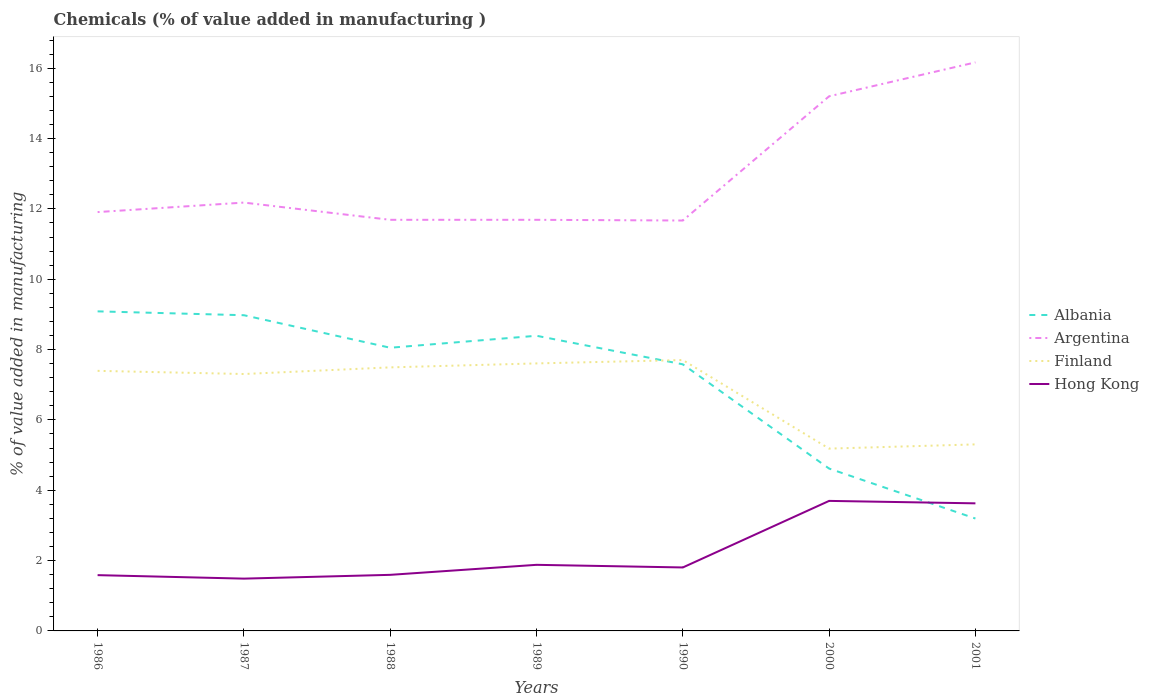How many different coloured lines are there?
Your response must be concise. 4. Does the line corresponding to Albania intersect with the line corresponding to Argentina?
Keep it short and to the point. No. Across all years, what is the maximum value added in manufacturing chemicals in Argentina?
Give a very brief answer. 11.67. In which year was the value added in manufacturing chemicals in Albania maximum?
Offer a terse response. 2001. What is the total value added in manufacturing chemicals in Argentina in the graph?
Your answer should be compact. 0.51. What is the difference between the highest and the second highest value added in manufacturing chemicals in Hong Kong?
Your answer should be compact. 2.21. What is the difference between the highest and the lowest value added in manufacturing chemicals in Finland?
Your response must be concise. 5. Does the graph contain grids?
Your response must be concise. No. What is the title of the graph?
Your answer should be very brief. Chemicals (% of value added in manufacturing ). What is the label or title of the Y-axis?
Offer a terse response. % of value added in manufacturing. What is the % of value added in manufacturing of Albania in 1986?
Ensure brevity in your answer.  9.09. What is the % of value added in manufacturing of Argentina in 1986?
Ensure brevity in your answer.  11.91. What is the % of value added in manufacturing of Finland in 1986?
Keep it short and to the point. 7.4. What is the % of value added in manufacturing of Hong Kong in 1986?
Your answer should be very brief. 1.59. What is the % of value added in manufacturing in Albania in 1987?
Your answer should be very brief. 8.98. What is the % of value added in manufacturing in Argentina in 1987?
Keep it short and to the point. 12.18. What is the % of value added in manufacturing in Finland in 1987?
Keep it short and to the point. 7.31. What is the % of value added in manufacturing in Hong Kong in 1987?
Provide a succinct answer. 1.49. What is the % of value added in manufacturing of Albania in 1988?
Provide a succinct answer. 8.05. What is the % of value added in manufacturing of Argentina in 1988?
Provide a short and direct response. 11.69. What is the % of value added in manufacturing of Finland in 1988?
Provide a succinct answer. 7.49. What is the % of value added in manufacturing in Hong Kong in 1988?
Offer a very short reply. 1.59. What is the % of value added in manufacturing of Albania in 1989?
Ensure brevity in your answer.  8.39. What is the % of value added in manufacturing of Argentina in 1989?
Your answer should be very brief. 11.69. What is the % of value added in manufacturing in Finland in 1989?
Give a very brief answer. 7.61. What is the % of value added in manufacturing in Hong Kong in 1989?
Offer a very short reply. 1.88. What is the % of value added in manufacturing in Albania in 1990?
Offer a terse response. 7.58. What is the % of value added in manufacturing in Argentina in 1990?
Provide a short and direct response. 11.67. What is the % of value added in manufacturing in Finland in 1990?
Offer a very short reply. 7.7. What is the % of value added in manufacturing of Hong Kong in 1990?
Your answer should be very brief. 1.8. What is the % of value added in manufacturing in Albania in 2000?
Offer a very short reply. 4.62. What is the % of value added in manufacturing of Argentina in 2000?
Your answer should be compact. 15.2. What is the % of value added in manufacturing in Finland in 2000?
Ensure brevity in your answer.  5.18. What is the % of value added in manufacturing in Hong Kong in 2000?
Your answer should be very brief. 3.7. What is the % of value added in manufacturing in Albania in 2001?
Offer a terse response. 3.2. What is the % of value added in manufacturing in Argentina in 2001?
Your answer should be very brief. 16.17. What is the % of value added in manufacturing in Finland in 2001?
Your response must be concise. 5.3. What is the % of value added in manufacturing of Hong Kong in 2001?
Offer a terse response. 3.63. Across all years, what is the maximum % of value added in manufacturing of Albania?
Keep it short and to the point. 9.09. Across all years, what is the maximum % of value added in manufacturing in Argentina?
Ensure brevity in your answer.  16.17. Across all years, what is the maximum % of value added in manufacturing in Finland?
Make the answer very short. 7.7. Across all years, what is the maximum % of value added in manufacturing in Hong Kong?
Offer a very short reply. 3.7. Across all years, what is the minimum % of value added in manufacturing in Albania?
Provide a short and direct response. 3.2. Across all years, what is the minimum % of value added in manufacturing in Argentina?
Your answer should be very brief. 11.67. Across all years, what is the minimum % of value added in manufacturing in Finland?
Offer a very short reply. 5.18. Across all years, what is the minimum % of value added in manufacturing of Hong Kong?
Make the answer very short. 1.49. What is the total % of value added in manufacturing of Albania in the graph?
Your response must be concise. 49.9. What is the total % of value added in manufacturing in Argentina in the graph?
Provide a short and direct response. 90.51. What is the total % of value added in manufacturing of Finland in the graph?
Ensure brevity in your answer.  47.99. What is the total % of value added in manufacturing in Hong Kong in the graph?
Give a very brief answer. 15.68. What is the difference between the % of value added in manufacturing of Albania in 1986 and that in 1987?
Offer a terse response. 0.11. What is the difference between the % of value added in manufacturing of Argentina in 1986 and that in 1987?
Your response must be concise. -0.27. What is the difference between the % of value added in manufacturing in Finland in 1986 and that in 1987?
Your response must be concise. 0.09. What is the difference between the % of value added in manufacturing of Hong Kong in 1986 and that in 1987?
Ensure brevity in your answer.  0.1. What is the difference between the % of value added in manufacturing in Albania in 1986 and that in 1988?
Provide a succinct answer. 1.03. What is the difference between the % of value added in manufacturing in Argentina in 1986 and that in 1988?
Give a very brief answer. 0.22. What is the difference between the % of value added in manufacturing in Finland in 1986 and that in 1988?
Your answer should be very brief. -0.1. What is the difference between the % of value added in manufacturing in Hong Kong in 1986 and that in 1988?
Keep it short and to the point. -0.01. What is the difference between the % of value added in manufacturing of Albania in 1986 and that in 1989?
Ensure brevity in your answer.  0.69. What is the difference between the % of value added in manufacturing in Argentina in 1986 and that in 1989?
Offer a very short reply. 0.22. What is the difference between the % of value added in manufacturing in Finland in 1986 and that in 1989?
Provide a succinct answer. -0.21. What is the difference between the % of value added in manufacturing in Hong Kong in 1986 and that in 1989?
Make the answer very short. -0.29. What is the difference between the % of value added in manufacturing of Albania in 1986 and that in 1990?
Offer a terse response. 1.51. What is the difference between the % of value added in manufacturing of Argentina in 1986 and that in 1990?
Your answer should be compact. 0.24. What is the difference between the % of value added in manufacturing in Finland in 1986 and that in 1990?
Give a very brief answer. -0.31. What is the difference between the % of value added in manufacturing in Hong Kong in 1986 and that in 1990?
Offer a very short reply. -0.22. What is the difference between the % of value added in manufacturing in Albania in 1986 and that in 2000?
Ensure brevity in your answer.  4.47. What is the difference between the % of value added in manufacturing of Argentina in 1986 and that in 2000?
Your answer should be very brief. -3.29. What is the difference between the % of value added in manufacturing in Finland in 1986 and that in 2000?
Provide a short and direct response. 2.21. What is the difference between the % of value added in manufacturing of Hong Kong in 1986 and that in 2000?
Keep it short and to the point. -2.11. What is the difference between the % of value added in manufacturing of Albania in 1986 and that in 2001?
Ensure brevity in your answer.  5.89. What is the difference between the % of value added in manufacturing of Argentina in 1986 and that in 2001?
Ensure brevity in your answer.  -4.26. What is the difference between the % of value added in manufacturing of Finland in 1986 and that in 2001?
Keep it short and to the point. 2.09. What is the difference between the % of value added in manufacturing in Hong Kong in 1986 and that in 2001?
Give a very brief answer. -2.04. What is the difference between the % of value added in manufacturing of Albania in 1987 and that in 1988?
Provide a succinct answer. 0.92. What is the difference between the % of value added in manufacturing in Argentina in 1987 and that in 1988?
Keep it short and to the point. 0.49. What is the difference between the % of value added in manufacturing of Finland in 1987 and that in 1988?
Make the answer very short. -0.19. What is the difference between the % of value added in manufacturing of Hong Kong in 1987 and that in 1988?
Provide a succinct answer. -0.11. What is the difference between the % of value added in manufacturing of Albania in 1987 and that in 1989?
Offer a terse response. 0.58. What is the difference between the % of value added in manufacturing of Argentina in 1987 and that in 1989?
Your response must be concise. 0.49. What is the difference between the % of value added in manufacturing of Finland in 1987 and that in 1989?
Give a very brief answer. -0.3. What is the difference between the % of value added in manufacturing in Hong Kong in 1987 and that in 1989?
Make the answer very short. -0.39. What is the difference between the % of value added in manufacturing of Albania in 1987 and that in 1990?
Offer a terse response. 1.4. What is the difference between the % of value added in manufacturing of Argentina in 1987 and that in 1990?
Make the answer very short. 0.51. What is the difference between the % of value added in manufacturing in Finland in 1987 and that in 1990?
Give a very brief answer. -0.4. What is the difference between the % of value added in manufacturing in Hong Kong in 1987 and that in 1990?
Offer a terse response. -0.32. What is the difference between the % of value added in manufacturing in Albania in 1987 and that in 2000?
Give a very brief answer. 4.36. What is the difference between the % of value added in manufacturing of Argentina in 1987 and that in 2000?
Provide a succinct answer. -3.02. What is the difference between the % of value added in manufacturing in Finland in 1987 and that in 2000?
Offer a terse response. 2.12. What is the difference between the % of value added in manufacturing in Hong Kong in 1987 and that in 2000?
Offer a terse response. -2.21. What is the difference between the % of value added in manufacturing of Albania in 1987 and that in 2001?
Offer a very short reply. 5.78. What is the difference between the % of value added in manufacturing of Argentina in 1987 and that in 2001?
Make the answer very short. -3.99. What is the difference between the % of value added in manufacturing in Finland in 1987 and that in 2001?
Your response must be concise. 2. What is the difference between the % of value added in manufacturing in Hong Kong in 1987 and that in 2001?
Ensure brevity in your answer.  -2.14. What is the difference between the % of value added in manufacturing in Albania in 1988 and that in 1989?
Make the answer very short. -0.34. What is the difference between the % of value added in manufacturing of Argentina in 1988 and that in 1989?
Your answer should be compact. 0. What is the difference between the % of value added in manufacturing of Finland in 1988 and that in 1989?
Offer a terse response. -0.11. What is the difference between the % of value added in manufacturing of Hong Kong in 1988 and that in 1989?
Keep it short and to the point. -0.28. What is the difference between the % of value added in manufacturing in Albania in 1988 and that in 1990?
Give a very brief answer. 0.47. What is the difference between the % of value added in manufacturing in Argentina in 1988 and that in 1990?
Make the answer very short. 0.02. What is the difference between the % of value added in manufacturing in Finland in 1988 and that in 1990?
Ensure brevity in your answer.  -0.21. What is the difference between the % of value added in manufacturing of Hong Kong in 1988 and that in 1990?
Keep it short and to the point. -0.21. What is the difference between the % of value added in manufacturing in Albania in 1988 and that in 2000?
Keep it short and to the point. 3.44. What is the difference between the % of value added in manufacturing of Argentina in 1988 and that in 2000?
Offer a very short reply. -3.51. What is the difference between the % of value added in manufacturing of Finland in 1988 and that in 2000?
Offer a terse response. 2.31. What is the difference between the % of value added in manufacturing of Hong Kong in 1988 and that in 2000?
Your answer should be compact. -2.1. What is the difference between the % of value added in manufacturing in Albania in 1988 and that in 2001?
Ensure brevity in your answer.  4.86. What is the difference between the % of value added in manufacturing of Argentina in 1988 and that in 2001?
Your answer should be very brief. -4.48. What is the difference between the % of value added in manufacturing of Finland in 1988 and that in 2001?
Provide a succinct answer. 2.19. What is the difference between the % of value added in manufacturing in Hong Kong in 1988 and that in 2001?
Make the answer very short. -2.03. What is the difference between the % of value added in manufacturing of Albania in 1989 and that in 1990?
Offer a terse response. 0.81. What is the difference between the % of value added in manufacturing of Finland in 1989 and that in 1990?
Keep it short and to the point. -0.1. What is the difference between the % of value added in manufacturing in Hong Kong in 1989 and that in 1990?
Your answer should be very brief. 0.07. What is the difference between the % of value added in manufacturing of Albania in 1989 and that in 2000?
Ensure brevity in your answer.  3.78. What is the difference between the % of value added in manufacturing of Argentina in 1989 and that in 2000?
Make the answer very short. -3.51. What is the difference between the % of value added in manufacturing of Finland in 1989 and that in 2000?
Offer a terse response. 2.42. What is the difference between the % of value added in manufacturing in Hong Kong in 1989 and that in 2000?
Your answer should be very brief. -1.82. What is the difference between the % of value added in manufacturing in Albania in 1989 and that in 2001?
Provide a succinct answer. 5.2. What is the difference between the % of value added in manufacturing in Argentina in 1989 and that in 2001?
Offer a terse response. -4.48. What is the difference between the % of value added in manufacturing of Finland in 1989 and that in 2001?
Your answer should be very brief. 2.3. What is the difference between the % of value added in manufacturing in Hong Kong in 1989 and that in 2001?
Offer a terse response. -1.75. What is the difference between the % of value added in manufacturing in Albania in 1990 and that in 2000?
Offer a very short reply. 2.96. What is the difference between the % of value added in manufacturing in Argentina in 1990 and that in 2000?
Make the answer very short. -3.53. What is the difference between the % of value added in manufacturing of Finland in 1990 and that in 2000?
Keep it short and to the point. 2.52. What is the difference between the % of value added in manufacturing in Hong Kong in 1990 and that in 2000?
Make the answer very short. -1.89. What is the difference between the % of value added in manufacturing in Albania in 1990 and that in 2001?
Provide a succinct answer. 4.39. What is the difference between the % of value added in manufacturing of Argentina in 1990 and that in 2001?
Ensure brevity in your answer.  -4.5. What is the difference between the % of value added in manufacturing in Finland in 1990 and that in 2001?
Provide a short and direct response. 2.4. What is the difference between the % of value added in manufacturing in Hong Kong in 1990 and that in 2001?
Provide a short and direct response. -1.82. What is the difference between the % of value added in manufacturing in Albania in 2000 and that in 2001?
Your answer should be compact. 1.42. What is the difference between the % of value added in manufacturing in Argentina in 2000 and that in 2001?
Ensure brevity in your answer.  -0.96. What is the difference between the % of value added in manufacturing in Finland in 2000 and that in 2001?
Keep it short and to the point. -0.12. What is the difference between the % of value added in manufacturing in Hong Kong in 2000 and that in 2001?
Your response must be concise. 0.07. What is the difference between the % of value added in manufacturing in Albania in 1986 and the % of value added in manufacturing in Argentina in 1987?
Offer a terse response. -3.09. What is the difference between the % of value added in manufacturing of Albania in 1986 and the % of value added in manufacturing of Finland in 1987?
Your answer should be compact. 1.78. What is the difference between the % of value added in manufacturing of Albania in 1986 and the % of value added in manufacturing of Hong Kong in 1987?
Ensure brevity in your answer.  7.6. What is the difference between the % of value added in manufacturing of Argentina in 1986 and the % of value added in manufacturing of Finland in 1987?
Your answer should be compact. 4.6. What is the difference between the % of value added in manufacturing in Argentina in 1986 and the % of value added in manufacturing in Hong Kong in 1987?
Your answer should be very brief. 10.42. What is the difference between the % of value added in manufacturing in Finland in 1986 and the % of value added in manufacturing in Hong Kong in 1987?
Ensure brevity in your answer.  5.91. What is the difference between the % of value added in manufacturing in Albania in 1986 and the % of value added in manufacturing in Argentina in 1988?
Ensure brevity in your answer.  -2.6. What is the difference between the % of value added in manufacturing of Albania in 1986 and the % of value added in manufacturing of Finland in 1988?
Your answer should be very brief. 1.59. What is the difference between the % of value added in manufacturing of Albania in 1986 and the % of value added in manufacturing of Hong Kong in 1988?
Offer a terse response. 7.49. What is the difference between the % of value added in manufacturing of Argentina in 1986 and the % of value added in manufacturing of Finland in 1988?
Offer a terse response. 4.42. What is the difference between the % of value added in manufacturing of Argentina in 1986 and the % of value added in manufacturing of Hong Kong in 1988?
Offer a very short reply. 10.32. What is the difference between the % of value added in manufacturing of Finland in 1986 and the % of value added in manufacturing of Hong Kong in 1988?
Keep it short and to the point. 5.8. What is the difference between the % of value added in manufacturing in Albania in 1986 and the % of value added in manufacturing in Argentina in 1989?
Your answer should be very brief. -2.6. What is the difference between the % of value added in manufacturing in Albania in 1986 and the % of value added in manufacturing in Finland in 1989?
Your answer should be very brief. 1.48. What is the difference between the % of value added in manufacturing of Albania in 1986 and the % of value added in manufacturing of Hong Kong in 1989?
Provide a succinct answer. 7.21. What is the difference between the % of value added in manufacturing in Argentina in 1986 and the % of value added in manufacturing in Finland in 1989?
Ensure brevity in your answer.  4.3. What is the difference between the % of value added in manufacturing of Argentina in 1986 and the % of value added in manufacturing of Hong Kong in 1989?
Your response must be concise. 10.03. What is the difference between the % of value added in manufacturing of Finland in 1986 and the % of value added in manufacturing of Hong Kong in 1989?
Offer a very short reply. 5.52. What is the difference between the % of value added in manufacturing in Albania in 1986 and the % of value added in manufacturing in Argentina in 1990?
Your answer should be compact. -2.58. What is the difference between the % of value added in manufacturing of Albania in 1986 and the % of value added in manufacturing of Finland in 1990?
Offer a very short reply. 1.38. What is the difference between the % of value added in manufacturing of Albania in 1986 and the % of value added in manufacturing of Hong Kong in 1990?
Keep it short and to the point. 7.28. What is the difference between the % of value added in manufacturing of Argentina in 1986 and the % of value added in manufacturing of Finland in 1990?
Offer a terse response. 4.21. What is the difference between the % of value added in manufacturing in Argentina in 1986 and the % of value added in manufacturing in Hong Kong in 1990?
Your answer should be compact. 10.11. What is the difference between the % of value added in manufacturing in Finland in 1986 and the % of value added in manufacturing in Hong Kong in 1990?
Your response must be concise. 5.59. What is the difference between the % of value added in manufacturing of Albania in 1986 and the % of value added in manufacturing of Argentina in 2000?
Ensure brevity in your answer.  -6.12. What is the difference between the % of value added in manufacturing in Albania in 1986 and the % of value added in manufacturing in Finland in 2000?
Ensure brevity in your answer.  3.9. What is the difference between the % of value added in manufacturing of Albania in 1986 and the % of value added in manufacturing of Hong Kong in 2000?
Your answer should be very brief. 5.39. What is the difference between the % of value added in manufacturing of Argentina in 1986 and the % of value added in manufacturing of Finland in 2000?
Your response must be concise. 6.73. What is the difference between the % of value added in manufacturing of Argentina in 1986 and the % of value added in manufacturing of Hong Kong in 2000?
Your answer should be compact. 8.21. What is the difference between the % of value added in manufacturing in Finland in 1986 and the % of value added in manufacturing in Hong Kong in 2000?
Offer a terse response. 3.7. What is the difference between the % of value added in manufacturing in Albania in 1986 and the % of value added in manufacturing in Argentina in 2001?
Provide a succinct answer. -7.08. What is the difference between the % of value added in manufacturing in Albania in 1986 and the % of value added in manufacturing in Finland in 2001?
Your answer should be very brief. 3.78. What is the difference between the % of value added in manufacturing in Albania in 1986 and the % of value added in manufacturing in Hong Kong in 2001?
Offer a terse response. 5.46. What is the difference between the % of value added in manufacturing in Argentina in 1986 and the % of value added in manufacturing in Finland in 2001?
Your response must be concise. 6.61. What is the difference between the % of value added in manufacturing in Argentina in 1986 and the % of value added in manufacturing in Hong Kong in 2001?
Provide a short and direct response. 8.28. What is the difference between the % of value added in manufacturing in Finland in 1986 and the % of value added in manufacturing in Hong Kong in 2001?
Offer a very short reply. 3.77. What is the difference between the % of value added in manufacturing of Albania in 1987 and the % of value added in manufacturing of Argentina in 1988?
Give a very brief answer. -2.71. What is the difference between the % of value added in manufacturing in Albania in 1987 and the % of value added in manufacturing in Finland in 1988?
Offer a very short reply. 1.48. What is the difference between the % of value added in manufacturing of Albania in 1987 and the % of value added in manufacturing of Hong Kong in 1988?
Ensure brevity in your answer.  7.38. What is the difference between the % of value added in manufacturing in Argentina in 1987 and the % of value added in manufacturing in Finland in 1988?
Keep it short and to the point. 4.69. What is the difference between the % of value added in manufacturing of Argentina in 1987 and the % of value added in manufacturing of Hong Kong in 1988?
Offer a very short reply. 10.59. What is the difference between the % of value added in manufacturing of Finland in 1987 and the % of value added in manufacturing of Hong Kong in 1988?
Give a very brief answer. 5.71. What is the difference between the % of value added in manufacturing in Albania in 1987 and the % of value added in manufacturing in Argentina in 1989?
Provide a short and direct response. -2.71. What is the difference between the % of value added in manufacturing of Albania in 1987 and the % of value added in manufacturing of Finland in 1989?
Make the answer very short. 1.37. What is the difference between the % of value added in manufacturing in Albania in 1987 and the % of value added in manufacturing in Hong Kong in 1989?
Your response must be concise. 7.1. What is the difference between the % of value added in manufacturing of Argentina in 1987 and the % of value added in manufacturing of Finland in 1989?
Give a very brief answer. 4.57. What is the difference between the % of value added in manufacturing in Argentina in 1987 and the % of value added in manufacturing in Hong Kong in 1989?
Your response must be concise. 10.3. What is the difference between the % of value added in manufacturing in Finland in 1987 and the % of value added in manufacturing in Hong Kong in 1989?
Your answer should be very brief. 5.43. What is the difference between the % of value added in manufacturing of Albania in 1987 and the % of value added in manufacturing of Argentina in 1990?
Give a very brief answer. -2.69. What is the difference between the % of value added in manufacturing of Albania in 1987 and the % of value added in manufacturing of Finland in 1990?
Your response must be concise. 1.27. What is the difference between the % of value added in manufacturing of Albania in 1987 and the % of value added in manufacturing of Hong Kong in 1990?
Keep it short and to the point. 7.17. What is the difference between the % of value added in manufacturing of Argentina in 1987 and the % of value added in manufacturing of Finland in 1990?
Offer a terse response. 4.48. What is the difference between the % of value added in manufacturing in Argentina in 1987 and the % of value added in manufacturing in Hong Kong in 1990?
Your response must be concise. 10.38. What is the difference between the % of value added in manufacturing in Finland in 1987 and the % of value added in manufacturing in Hong Kong in 1990?
Make the answer very short. 5.5. What is the difference between the % of value added in manufacturing in Albania in 1987 and the % of value added in manufacturing in Argentina in 2000?
Your response must be concise. -6.23. What is the difference between the % of value added in manufacturing in Albania in 1987 and the % of value added in manufacturing in Finland in 2000?
Offer a terse response. 3.79. What is the difference between the % of value added in manufacturing of Albania in 1987 and the % of value added in manufacturing of Hong Kong in 2000?
Your response must be concise. 5.28. What is the difference between the % of value added in manufacturing of Argentina in 1987 and the % of value added in manufacturing of Finland in 2000?
Provide a succinct answer. 7. What is the difference between the % of value added in manufacturing in Argentina in 1987 and the % of value added in manufacturing in Hong Kong in 2000?
Your answer should be compact. 8.48. What is the difference between the % of value added in manufacturing in Finland in 1987 and the % of value added in manufacturing in Hong Kong in 2000?
Your answer should be compact. 3.61. What is the difference between the % of value added in manufacturing of Albania in 1987 and the % of value added in manufacturing of Argentina in 2001?
Give a very brief answer. -7.19. What is the difference between the % of value added in manufacturing in Albania in 1987 and the % of value added in manufacturing in Finland in 2001?
Offer a terse response. 3.67. What is the difference between the % of value added in manufacturing in Albania in 1987 and the % of value added in manufacturing in Hong Kong in 2001?
Your answer should be compact. 5.35. What is the difference between the % of value added in manufacturing of Argentina in 1987 and the % of value added in manufacturing of Finland in 2001?
Offer a very short reply. 6.88. What is the difference between the % of value added in manufacturing in Argentina in 1987 and the % of value added in manufacturing in Hong Kong in 2001?
Keep it short and to the point. 8.55. What is the difference between the % of value added in manufacturing of Finland in 1987 and the % of value added in manufacturing of Hong Kong in 2001?
Offer a terse response. 3.68. What is the difference between the % of value added in manufacturing in Albania in 1988 and the % of value added in manufacturing in Argentina in 1989?
Ensure brevity in your answer.  -3.64. What is the difference between the % of value added in manufacturing of Albania in 1988 and the % of value added in manufacturing of Finland in 1989?
Ensure brevity in your answer.  0.45. What is the difference between the % of value added in manufacturing in Albania in 1988 and the % of value added in manufacturing in Hong Kong in 1989?
Make the answer very short. 6.17. What is the difference between the % of value added in manufacturing of Argentina in 1988 and the % of value added in manufacturing of Finland in 1989?
Give a very brief answer. 4.08. What is the difference between the % of value added in manufacturing of Argentina in 1988 and the % of value added in manufacturing of Hong Kong in 1989?
Give a very brief answer. 9.81. What is the difference between the % of value added in manufacturing of Finland in 1988 and the % of value added in manufacturing of Hong Kong in 1989?
Offer a terse response. 5.61. What is the difference between the % of value added in manufacturing of Albania in 1988 and the % of value added in manufacturing of Argentina in 1990?
Your response must be concise. -3.62. What is the difference between the % of value added in manufacturing in Albania in 1988 and the % of value added in manufacturing in Finland in 1990?
Keep it short and to the point. 0.35. What is the difference between the % of value added in manufacturing in Albania in 1988 and the % of value added in manufacturing in Hong Kong in 1990?
Your answer should be compact. 6.25. What is the difference between the % of value added in manufacturing of Argentina in 1988 and the % of value added in manufacturing of Finland in 1990?
Offer a very short reply. 3.99. What is the difference between the % of value added in manufacturing in Argentina in 1988 and the % of value added in manufacturing in Hong Kong in 1990?
Ensure brevity in your answer.  9.89. What is the difference between the % of value added in manufacturing of Finland in 1988 and the % of value added in manufacturing of Hong Kong in 1990?
Provide a succinct answer. 5.69. What is the difference between the % of value added in manufacturing in Albania in 1988 and the % of value added in manufacturing in Argentina in 2000?
Offer a terse response. -7.15. What is the difference between the % of value added in manufacturing of Albania in 1988 and the % of value added in manufacturing of Finland in 2000?
Make the answer very short. 2.87. What is the difference between the % of value added in manufacturing in Albania in 1988 and the % of value added in manufacturing in Hong Kong in 2000?
Your response must be concise. 4.36. What is the difference between the % of value added in manufacturing of Argentina in 1988 and the % of value added in manufacturing of Finland in 2000?
Keep it short and to the point. 6.51. What is the difference between the % of value added in manufacturing in Argentina in 1988 and the % of value added in manufacturing in Hong Kong in 2000?
Your answer should be very brief. 7.99. What is the difference between the % of value added in manufacturing in Finland in 1988 and the % of value added in manufacturing in Hong Kong in 2000?
Provide a succinct answer. 3.8. What is the difference between the % of value added in manufacturing in Albania in 1988 and the % of value added in manufacturing in Argentina in 2001?
Give a very brief answer. -8.11. What is the difference between the % of value added in manufacturing of Albania in 1988 and the % of value added in manufacturing of Finland in 2001?
Offer a very short reply. 2.75. What is the difference between the % of value added in manufacturing of Albania in 1988 and the % of value added in manufacturing of Hong Kong in 2001?
Provide a succinct answer. 4.42. What is the difference between the % of value added in manufacturing in Argentina in 1988 and the % of value added in manufacturing in Finland in 2001?
Ensure brevity in your answer.  6.39. What is the difference between the % of value added in manufacturing of Argentina in 1988 and the % of value added in manufacturing of Hong Kong in 2001?
Offer a terse response. 8.06. What is the difference between the % of value added in manufacturing in Finland in 1988 and the % of value added in manufacturing in Hong Kong in 2001?
Provide a short and direct response. 3.87. What is the difference between the % of value added in manufacturing in Albania in 1989 and the % of value added in manufacturing in Argentina in 1990?
Your response must be concise. -3.28. What is the difference between the % of value added in manufacturing in Albania in 1989 and the % of value added in manufacturing in Finland in 1990?
Ensure brevity in your answer.  0.69. What is the difference between the % of value added in manufacturing of Albania in 1989 and the % of value added in manufacturing of Hong Kong in 1990?
Your answer should be compact. 6.59. What is the difference between the % of value added in manufacturing in Argentina in 1989 and the % of value added in manufacturing in Finland in 1990?
Provide a short and direct response. 3.99. What is the difference between the % of value added in manufacturing of Argentina in 1989 and the % of value added in manufacturing of Hong Kong in 1990?
Your answer should be compact. 9.89. What is the difference between the % of value added in manufacturing in Finland in 1989 and the % of value added in manufacturing in Hong Kong in 1990?
Your answer should be very brief. 5.8. What is the difference between the % of value added in manufacturing of Albania in 1989 and the % of value added in manufacturing of Argentina in 2000?
Make the answer very short. -6.81. What is the difference between the % of value added in manufacturing of Albania in 1989 and the % of value added in manufacturing of Finland in 2000?
Provide a succinct answer. 3.21. What is the difference between the % of value added in manufacturing of Albania in 1989 and the % of value added in manufacturing of Hong Kong in 2000?
Ensure brevity in your answer.  4.7. What is the difference between the % of value added in manufacturing of Argentina in 1989 and the % of value added in manufacturing of Finland in 2000?
Keep it short and to the point. 6.51. What is the difference between the % of value added in manufacturing of Argentina in 1989 and the % of value added in manufacturing of Hong Kong in 2000?
Provide a short and direct response. 7.99. What is the difference between the % of value added in manufacturing in Finland in 1989 and the % of value added in manufacturing in Hong Kong in 2000?
Keep it short and to the point. 3.91. What is the difference between the % of value added in manufacturing of Albania in 1989 and the % of value added in manufacturing of Argentina in 2001?
Provide a short and direct response. -7.77. What is the difference between the % of value added in manufacturing in Albania in 1989 and the % of value added in manufacturing in Finland in 2001?
Provide a short and direct response. 3.09. What is the difference between the % of value added in manufacturing of Albania in 1989 and the % of value added in manufacturing of Hong Kong in 2001?
Offer a terse response. 4.77. What is the difference between the % of value added in manufacturing of Argentina in 1989 and the % of value added in manufacturing of Finland in 2001?
Make the answer very short. 6.39. What is the difference between the % of value added in manufacturing of Argentina in 1989 and the % of value added in manufacturing of Hong Kong in 2001?
Offer a very short reply. 8.06. What is the difference between the % of value added in manufacturing in Finland in 1989 and the % of value added in manufacturing in Hong Kong in 2001?
Keep it short and to the point. 3.98. What is the difference between the % of value added in manufacturing of Albania in 1990 and the % of value added in manufacturing of Argentina in 2000?
Make the answer very short. -7.62. What is the difference between the % of value added in manufacturing of Albania in 1990 and the % of value added in manufacturing of Finland in 2000?
Provide a succinct answer. 2.4. What is the difference between the % of value added in manufacturing in Albania in 1990 and the % of value added in manufacturing in Hong Kong in 2000?
Your answer should be compact. 3.88. What is the difference between the % of value added in manufacturing of Argentina in 1990 and the % of value added in manufacturing of Finland in 2000?
Offer a very short reply. 6.49. What is the difference between the % of value added in manufacturing of Argentina in 1990 and the % of value added in manufacturing of Hong Kong in 2000?
Offer a terse response. 7.97. What is the difference between the % of value added in manufacturing in Finland in 1990 and the % of value added in manufacturing in Hong Kong in 2000?
Give a very brief answer. 4.01. What is the difference between the % of value added in manufacturing in Albania in 1990 and the % of value added in manufacturing in Argentina in 2001?
Ensure brevity in your answer.  -8.59. What is the difference between the % of value added in manufacturing of Albania in 1990 and the % of value added in manufacturing of Finland in 2001?
Keep it short and to the point. 2.28. What is the difference between the % of value added in manufacturing of Albania in 1990 and the % of value added in manufacturing of Hong Kong in 2001?
Offer a terse response. 3.95. What is the difference between the % of value added in manufacturing in Argentina in 1990 and the % of value added in manufacturing in Finland in 2001?
Make the answer very short. 6.37. What is the difference between the % of value added in manufacturing of Argentina in 1990 and the % of value added in manufacturing of Hong Kong in 2001?
Your answer should be compact. 8.04. What is the difference between the % of value added in manufacturing in Finland in 1990 and the % of value added in manufacturing in Hong Kong in 2001?
Your answer should be very brief. 4.07. What is the difference between the % of value added in manufacturing of Albania in 2000 and the % of value added in manufacturing of Argentina in 2001?
Give a very brief answer. -11.55. What is the difference between the % of value added in manufacturing of Albania in 2000 and the % of value added in manufacturing of Finland in 2001?
Make the answer very short. -0.69. What is the difference between the % of value added in manufacturing in Argentina in 2000 and the % of value added in manufacturing in Finland in 2001?
Give a very brief answer. 9.9. What is the difference between the % of value added in manufacturing in Argentina in 2000 and the % of value added in manufacturing in Hong Kong in 2001?
Ensure brevity in your answer.  11.58. What is the difference between the % of value added in manufacturing in Finland in 2000 and the % of value added in manufacturing in Hong Kong in 2001?
Offer a very short reply. 1.56. What is the average % of value added in manufacturing in Albania per year?
Keep it short and to the point. 7.13. What is the average % of value added in manufacturing in Argentina per year?
Make the answer very short. 12.93. What is the average % of value added in manufacturing in Finland per year?
Your answer should be very brief. 6.86. What is the average % of value added in manufacturing of Hong Kong per year?
Your answer should be compact. 2.24. In the year 1986, what is the difference between the % of value added in manufacturing of Albania and % of value added in manufacturing of Argentina?
Provide a short and direct response. -2.82. In the year 1986, what is the difference between the % of value added in manufacturing of Albania and % of value added in manufacturing of Finland?
Ensure brevity in your answer.  1.69. In the year 1986, what is the difference between the % of value added in manufacturing in Albania and % of value added in manufacturing in Hong Kong?
Your response must be concise. 7.5. In the year 1986, what is the difference between the % of value added in manufacturing in Argentina and % of value added in manufacturing in Finland?
Ensure brevity in your answer.  4.51. In the year 1986, what is the difference between the % of value added in manufacturing of Argentina and % of value added in manufacturing of Hong Kong?
Ensure brevity in your answer.  10.32. In the year 1986, what is the difference between the % of value added in manufacturing of Finland and % of value added in manufacturing of Hong Kong?
Ensure brevity in your answer.  5.81. In the year 1987, what is the difference between the % of value added in manufacturing in Albania and % of value added in manufacturing in Argentina?
Keep it short and to the point. -3.2. In the year 1987, what is the difference between the % of value added in manufacturing of Albania and % of value added in manufacturing of Finland?
Offer a very short reply. 1.67. In the year 1987, what is the difference between the % of value added in manufacturing in Albania and % of value added in manufacturing in Hong Kong?
Offer a terse response. 7.49. In the year 1987, what is the difference between the % of value added in manufacturing of Argentina and % of value added in manufacturing of Finland?
Your response must be concise. 4.87. In the year 1987, what is the difference between the % of value added in manufacturing in Argentina and % of value added in manufacturing in Hong Kong?
Your answer should be very brief. 10.69. In the year 1987, what is the difference between the % of value added in manufacturing in Finland and % of value added in manufacturing in Hong Kong?
Keep it short and to the point. 5.82. In the year 1988, what is the difference between the % of value added in manufacturing of Albania and % of value added in manufacturing of Argentina?
Give a very brief answer. -3.64. In the year 1988, what is the difference between the % of value added in manufacturing of Albania and % of value added in manufacturing of Finland?
Provide a succinct answer. 0.56. In the year 1988, what is the difference between the % of value added in manufacturing of Albania and % of value added in manufacturing of Hong Kong?
Keep it short and to the point. 6.46. In the year 1988, what is the difference between the % of value added in manufacturing in Argentina and % of value added in manufacturing in Finland?
Provide a succinct answer. 4.2. In the year 1988, what is the difference between the % of value added in manufacturing in Argentina and % of value added in manufacturing in Hong Kong?
Your answer should be compact. 10.1. In the year 1988, what is the difference between the % of value added in manufacturing in Finland and % of value added in manufacturing in Hong Kong?
Ensure brevity in your answer.  5.9. In the year 1989, what is the difference between the % of value added in manufacturing of Albania and % of value added in manufacturing of Argentina?
Offer a terse response. -3.3. In the year 1989, what is the difference between the % of value added in manufacturing in Albania and % of value added in manufacturing in Finland?
Provide a succinct answer. 0.79. In the year 1989, what is the difference between the % of value added in manufacturing of Albania and % of value added in manufacturing of Hong Kong?
Provide a short and direct response. 6.51. In the year 1989, what is the difference between the % of value added in manufacturing of Argentina and % of value added in manufacturing of Finland?
Provide a short and direct response. 4.08. In the year 1989, what is the difference between the % of value added in manufacturing of Argentina and % of value added in manufacturing of Hong Kong?
Provide a succinct answer. 9.81. In the year 1989, what is the difference between the % of value added in manufacturing of Finland and % of value added in manufacturing of Hong Kong?
Provide a short and direct response. 5.73. In the year 1990, what is the difference between the % of value added in manufacturing of Albania and % of value added in manufacturing of Argentina?
Make the answer very short. -4.09. In the year 1990, what is the difference between the % of value added in manufacturing of Albania and % of value added in manufacturing of Finland?
Ensure brevity in your answer.  -0.12. In the year 1990, what is the difference between the % of value added in manufacturing of Albania and % of value added in manufacturing of Hong Kong?
Make the answer very short. 5.78. In the year 1990, what is the difference between the % of value added in manufacturing in Argentina and % of value added in manufacturing in Finland?
Offer a very short reply. 3.97. In the year 1990, what is the difference between the % of value added in manufacturing in Argentina and % of value added in manufacturing in Hong Kong?
Your answer should be compact. 9.87. In the year 1990, what is the difference between the % of value added in manufacturing of Finland and % of value added in manufacturing of Hong Kong?
Your response must be concise. 5.9. In the year 2000, what is the difference between the % of value added in manufacturing of Albania and % of value added in manufacturing of Argentina?
Provide a succinct answer. -10.59. In the year 2000, what is the difference between the % of value added in manufacturing of Albania and % of value added in manufacturing of Finland?
Your response must be concise. -0.57. In the year 2000, what is the difference between the % of value added in manufacturing in Albania and % of value added in manufacturing in Hong Kong?
Keep it short and to the point. 0.92. In the year 2000, what is the difference between the % of value added in manufacturing in Argentina and % of value added in manufacturing in Finland?
Keep it short and to the point. 10.02. In the year 2000, what is the difference between the % of value added in manufacturing of Argentina and % of value added in manufacturing of Hong Kong?
Offer a very short reply. 11.51. In the year 2000, what is the difference between the % of value added in manufacturing of Finland and % of value added in manufacturing of Hong Kong?
Give a very brief answer. 1.49. In the year 2001, what is the difference between the % of value added in manufacturing of Albania and % of value added in manufacturing of Argentina?
Your answer should be compact. -12.97. In the year 2001, what is the difference between the % of value added in manufacturing of Albania and % of value added in manufacturing of Finland?
Provide a succinct answer. -2.11. In the year 2001, what is the difference between the % of value added in manufacturing of Albania and % of value added in manufacturing of Hong Kong?
Offer a terse response. -0.43. In the year 2001, what is the difference between the % of value added in manufacturing in Argentina and % of value added in manufacturing in Finland?
Your response must be concise. 10.86. In the year 2001, what is the difference between the % of value added in manufacturing in Argentina and % of value added in manufacturing in Hong Kong?
Provide a succinct answer. 12.54. In the year 2001, what is the difference between the % of value added in manufacturing of Finland and % of value added in manufacturing of Hong Kong?
Keep it short and to the point. 1.68. What is the ratio of the % of value added in manufacturing in Albania in 1986 to that in 1987?
Provide a succinct answer. 1.01. What is the ratio of the % of value added in manufacturing of Argentina in 1986 to that in 1987?
Your answer should be very brief. 0.98. What is the ratio of the % of value added in manufacturing of Finland in 1986 to that in 1987?
Provide a succinct answer. 1.01. What is the ratio of the % of value added in manufacturing of Hong Kong in 1986 to that in 1987?
Keep it short and to the point. 1.07. What is the ratio of the % of value added in manufacturing in Albania in 1986 to that in 1988?
Make the answer very short. 1.13. What is the ratio of the % of value added in manufacturing of Argentina in 1986 to that in 1988?
Give a very brief answer. 1.02. What is the ratio of the % of value added in manufacturing in Finland in 1986 to that in 1988?
Offer a very short reply. 0.99. What is the ratio of the % of value added in manufacturing in Hong Kong in 1986 to that in 1988?
Keep it short and to the point. 0.99. What is the ratio of the % of value added in manufacturing in Albania in 1986 to that in 1989?
Ensure brevity in your answer.  1.08. What is the ratio of the % of value added in manufacturing in Argentina in 1986 to that in 1989?
Your answer should be very brief. 1.02. What is the ratio of the % of value added in manufacturing of Finland in 1986 to that in 1989?
Make the answer very short. 0.97. What is the ratio of the % of value added in manufacturing in Hong Kong in 1986 to that in 1989?
Ensure brevity in your answer.  0.84. What is the ratio of the % of value added in manufacturing in Albania in 1986 to that in 1990?
Make the answer very short. 1.2. What is the ratio of the % of value added in manufacturing in Argentina in 1986 to that in 1990?
Give a very brief answer. 1.02. What is the ratio of the % of value added in manufacturing of Finland in 1986 to that in 1990?
Ensure brevity in your answer.  0.96. What is the ratio of the % of value added in manufacturing of Hong Kong in 1986 to that in 1990?
Make the answer very short. 0.88. What is the ratio of the % of value added in manufacturing of Albania in 1986 to that in 2000?
Provide a succinct answer. 1.97. What is the ratio of the % of value added in manufacturing of Argentina in 1986 to that in 2000?
Provide a short and direct response. 0.78. What is the ratio of the % of value added in manufacturing of Finland in 1986 to that in 2000?
Ensure brevity in your answer.  1.43. What is the ratio of the % of value added in manufacturing of Hong Kong in 1986 to that in 2000?
Offer a terse response. 0.43. What is the ratio of the % of value added in manufacturing of Albania in 1986 to that in 2001?
Your answer should be compact. 2.84. What is the ratio of the % of value added in manufacturing of Argentina in 1986 to that in 2001?
Your response must be concise. 0.74. What is the ratio of the % of value added in manufacturing in Finland in 1986 to that in 2001?
Keep it short and to the point. 1.39. What is the ratio of the % of value added in manufacturing of Hong Kong in 1986 to that in 2001?
Make the answer very short. 0.44. What is the ratio of the % of value added in manufacturing in Albania in 1987 to that in 1988?
Provide a short and direct response. 1.11. What is the ratio of the % of value added in manufacturing of Argentina in 1987 to that in 1988?
Your response must be concise. 1.04. What is the ratio of the % of value added in manufacturing in Finland in 1987 to that in 1988?
Your response must be concise. 0.97. What is the ratio of the % of value added in manufacturing of Hong Kong in 1987 to that in 1988?
Offer a very short reply. 0.93. What is the ratio of the % of value added in manufacturing of Albania in 1987 to that in 1989?
Offer a very short reply. 1.07. What is the ratio of the % of value added in manufacturing in Argentina in 1987 to that in 1989?
Provide a short and direct response. 1.04. What is the ratio of the % of value added in manufacturing in Finland in 1987 to that in 1989?
Make the answer very short. 0.96. What is the ratio of the % of value added in manufacturing in Hong Kong in 1987 to that in 1989?
Give a very brief answer. 0.79. What is the ratio of the % of value added in manufacturing of Albania in 1987 to that in 1990?
Your answer should be compact. 1.18. What is the ratio of the % of value added in manufacturing in Argentina in 1987 to that in 1990?
Offer a very short reply. 1.04. What is the ratio of the % of value added in manufacturing of Finland in 1987 to that in 1990?
Ensure brevity in your answer.  0.95. What is the ratio of the % of value added in manufacturing in Hong Kong in 1987 to that in 1990?
Offer a terse response. 0.82. What is the ratio of the % of value added in manufacturing in Albania in 1987 to that in 2000?
Offer a terse response. 1.94. What is the ratio of the % of value added in manufacturing of Argentina in 1987 to that in 2000?
Your response must be concise. 0.8. What is the ratio of the % of value added in manufacturing of Finland in 1987 to that in 2000?
Your answer should be compact. 1.41. What is the ratio of the % of value added in manufacturing of Hong Kong in 1987 to that in 2000?
Ensure brevity in your answer.  0.4. What is the ratio of the % of value added in manufacturing in Albania in 1987 to that in 2001?
Offer a terse response. 2.81. What is the ratio of the % of value added in manufacturing in Argentina in 1987 to that in 2001?
Keep it short and to the point. 0.75. What is the ratio of the % of value added in manufacturing in Finland in 1987 to that in 2001?
Make the answer very short. 1.38. What is the ratio of the % of value added in manufacturing of Hong Kong in 1987 to that in 2001?
Ensure brevity in your answer.  0.41. What is the ratio of the % of value added in manufacturing of Albania in 1988 to that in 1989?
Offer a terse response. 0.96. What is the ratio of the % of value added in manufacturing in Finland in 1988 to that in 1989?
Keep it short and to the point. 0.99. What is the ratio of the % of value added in manufacturing in Hong Kong in 1988 to that in 1989?
Provide a succinct answer. 0.85. What is the ratio of the % of value added in manufacturing in Albania in 1988 to that in 1990?
Provide a short and direct response. 1.06. What is the ratio of the % of value added in manufacturing in Argentina in 1988 to that in 1990?
Provide a succinct answer. 1. What is the ratio of the % of value added in manufacturing in Hong Kong in 1988 to that in 1990?
Your response must be concise. 0.88. What is the ratio of the % of value added in manufacturing of Albania in 1988 to that in 2000?
Offer a terse response. 1.74. What is the ratio of the % of value added in manufacturing of Argentina in 1988 to that in 2000?
Give a very brief answer. 0.77. What is the ratio of the % of value added in manufacturing in Finland in 1988 to that in 2000?
Your answer should be very brief. 1.45. What is the ratio of the % of value added in manufacturing of Hong Kong in 1988 to that in 2000?
Offer a terse response. 0.43. What is the ratio of the % of value added in manufacturing of Albania in 1988 to that in 2001?
Your response must be concise. 2.52. What is the ratio of the % of value added in manufacturing of Argentina in 1988 to that in 2001?
Offer a very short reply. 0.72. What is the ratio of the % of value added in manufacturing in Finland in 1988 to that in 2001?
Provide a short and direct response. 1.41. What is the ratio of the % of value added in manufacturing of Hong Kong in 1988 to that in 2001?
Give a very brief answer. 0.44. What is the ratio of the % of value added in manufacturing in Albania in 1989 to that in 1990?
Provide a succinct answer. 1.11. What is the ratio of the % of value added in manufacturing in Finland in 1989 to that in 1990?
Keep it short and to the point. 0.99. What is the ratio of the % of value added in manufacturing in Hong Kong in 1989 to that in 1990?
Ensure brevity in your answer.  1.04. What is the ratio of the % of value added in manufacturing in Albania in 1989 to that in 2000?
Your response must be concise. 1.82. What is the ratio of the % of value added in manufacturing of Argentina in 1989 to that in 2000?
Your answer should be compact. 0.77. What is the ratio of the % of value added in manufacturing of Finland in 1989 to that in 2000?
Offer a terse response. 1.47. What is the ratio of the % of value added in manufacturing of Hong Kong in 1989 to that in 2000?
Your response must be concise. 0.51. What is the ratio of the % of value added in manufacturing of Albania in 1989 to that in 2001?
Your answer should be very brief. 2.63. What is the ratio of the % of value added in manufacturing in Argentina in 1989 to that in 2001?
Your response must be concise. 0.72. What is the ratio of the % of value added in manufacturing of Finland in 1989 to that in 2001?
Give a very brief answer. 1.43. What is the ratio of the % of value added in manufacturing of Hong Kong in 1989 to that in 2001?
Make the answer very short. 0.52. What is the ratio of the % of value added in manufacturing of Albania in 1990 to that in 2000?
Offer a very short reply. 1.64. What is the ratio of the % of value added in manufacturing in Argentina in 1990 to that in 2000?
Offer a terse response. 0.77. What is the ratio of the % of value added in manufacturing in Finland in 1990 to that in 2000?
Provide a succinct answer. 1.49. What is the ratio of the % of value added in manufacturing in Hong Kong in 1990 to that in 2000?
Your response must be concise. 0.49. What is the ratio of the % of value added in manufacturing of Albania in 1990 to that in 2001?
Your answer should be very brief. 2.37. What is the ratio of the % of value added in manufacturing of Argentina in 1990 to that in 2001?
Keep it short and to the point. 0.72. What is the ratio of the % of value added in manufacturing in Finland in 1990 to that in 2001?
Your answer should be very brief. 1.45. What is the ratio of the % of value added in manufacturing in Hong Kong in 1990 to that in 2001?
Your answer should be compact. 0.5. What is the ratio of the % of value added in manufacturing in Albania in 2000 to that in 2001?
Offer a very short reply. 1.44. What is the ratio of the % of value added in manufacturing in Argentina in 2000 to that in 2001?
Your answer should be very brief. 0.94. What is the ratio of the % of value added in manufacturing of Finland in 2000 to that in 2001?
Keep it short and to the point. 0.98. What is the ratio of the % of value added in manufacturing in Hong Kong in 2000 to that in 2001?
Offer a terse response. 1.02. What is the difference between the highest and the second highest % of value added in manufacturing in Albania?
Offer a very short reply. 0.11. What is the difference between the highest and the second highest % of value added in manufacturing of Argentina?
Offer a terse response. 0.96. What is the difference between the highest and the second highest % of value added in manufacturing in Finland?
Make the answer very short. 0.1. What is the difference between the highest and the second highest % of value added in manufacturing of Hong Kong?
Your response must be concise. 0.07. What is the difference between the highest and the lowest % of value added in manufacturing in Albania?
Ensure brevity in your answer.  5.89. What is the difference between the highest and the lowest % of value added in manufacturing in Argentina?
Keep it short and to the point. 4.5. What is the difference between the highest and the lowest % of value added in manufacturing in Finland?
Your answer should be very brief. 2.52. What is the difference between the highest and the lowest % of value added in manufacturing of Hong Kong?
Your response must be concise. 2.21. 